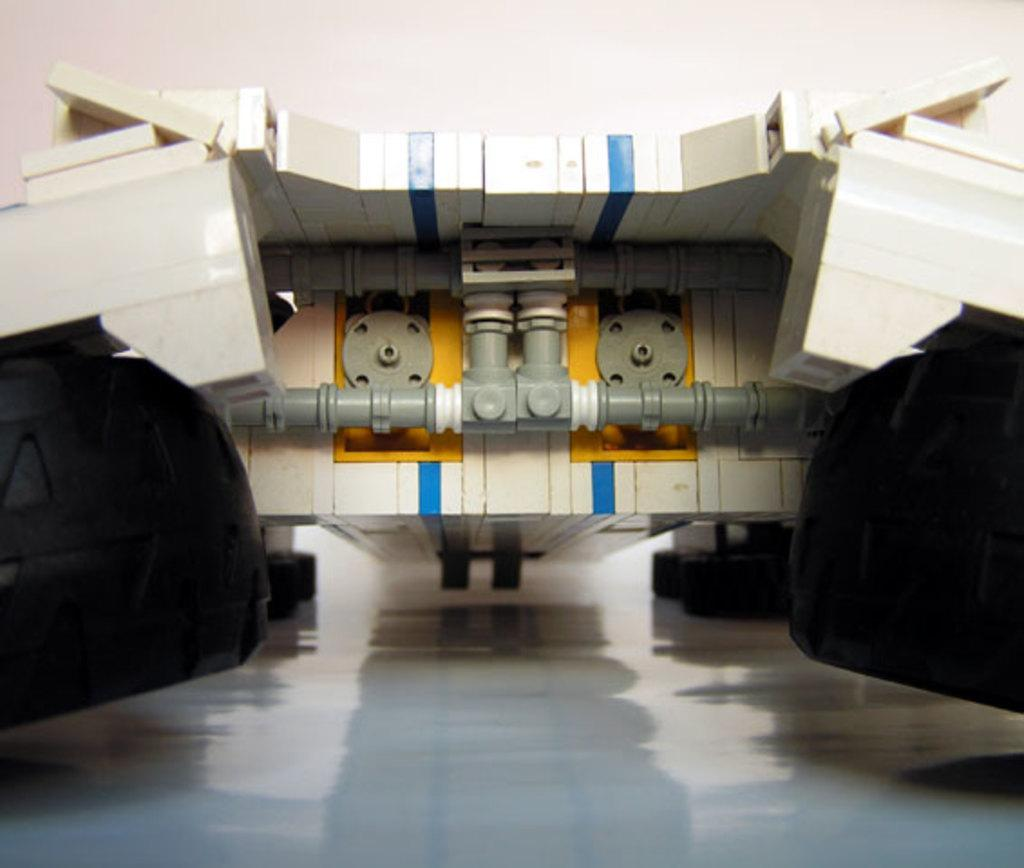Can you identify any objects on the floor in the image? There might be a toy present on the floor. What type of holiday is being celebrated in the image? There is no indication of a holiday being celebrated in the image. Can you see a hose in the image? There is no mention of a hose in the provided facts, so it cannot be determined if one is present in the image. 